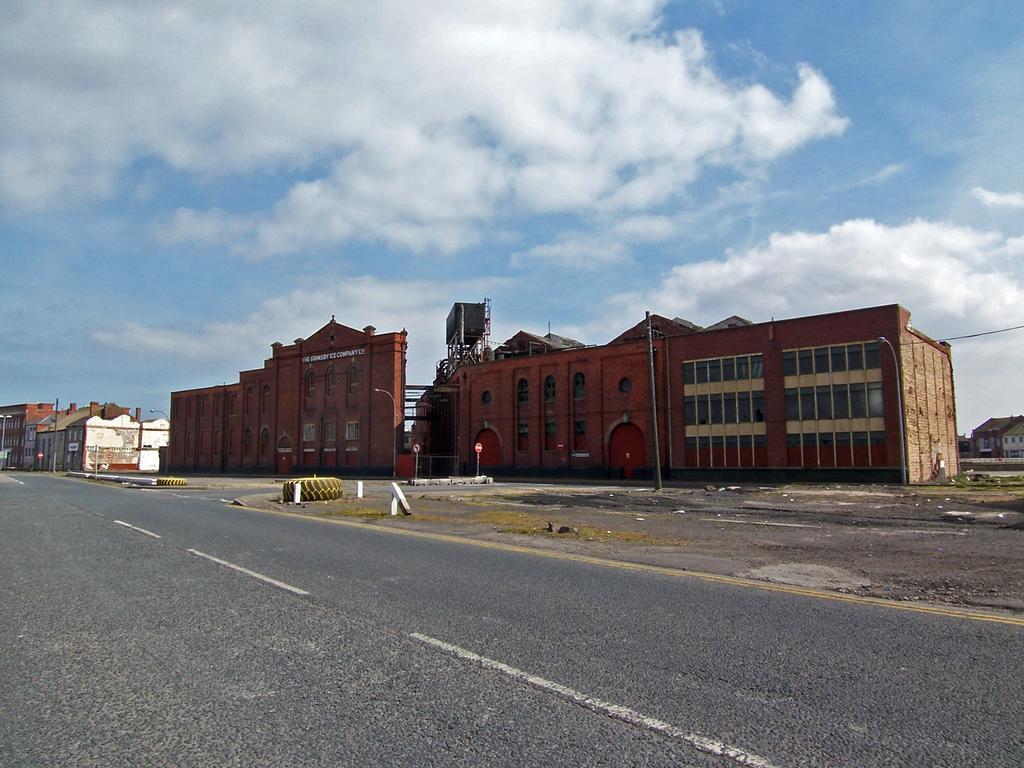Please provide a concise description of this image. In this picture we can see road, tyres, poles, boards, light and buildings. In the background of the image we can see the sky with clouds. 